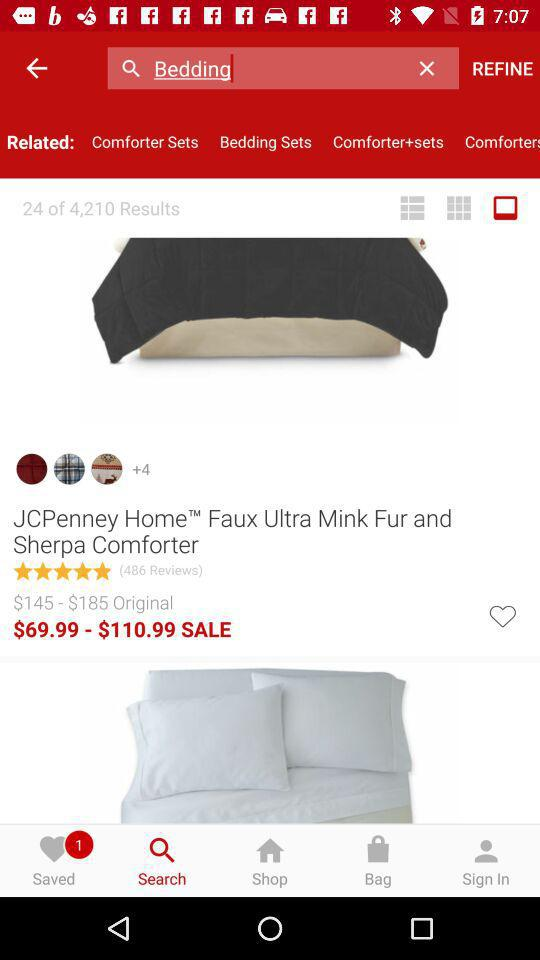How many reviews are there for "JCPenney Home™ Faux Ultra Mink Fur and Sherpa Comforter"? There are 486 reviews. 